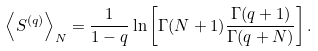Convert formula to latex. <formula><loc_0><loc_0><loc_500><loc_500>\left \langle S ^ { ( q ) } \right \rangle _ { N } = { \frac { 1 } { 1 - q } } \ln \left [ \Gamma ( N + 1 ) \frac { \Gamma ( q + 1 ) } { \Gamma ( q + N ) } \right ] .</formula> 